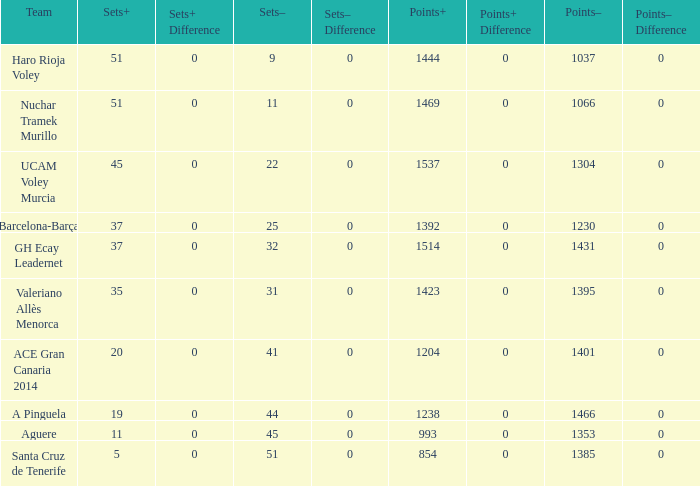What is the highest Points+ number that has a Sets+ number larger than 45, a Sets- number larger than 9, and a Points- number smaller than 1066? None. 